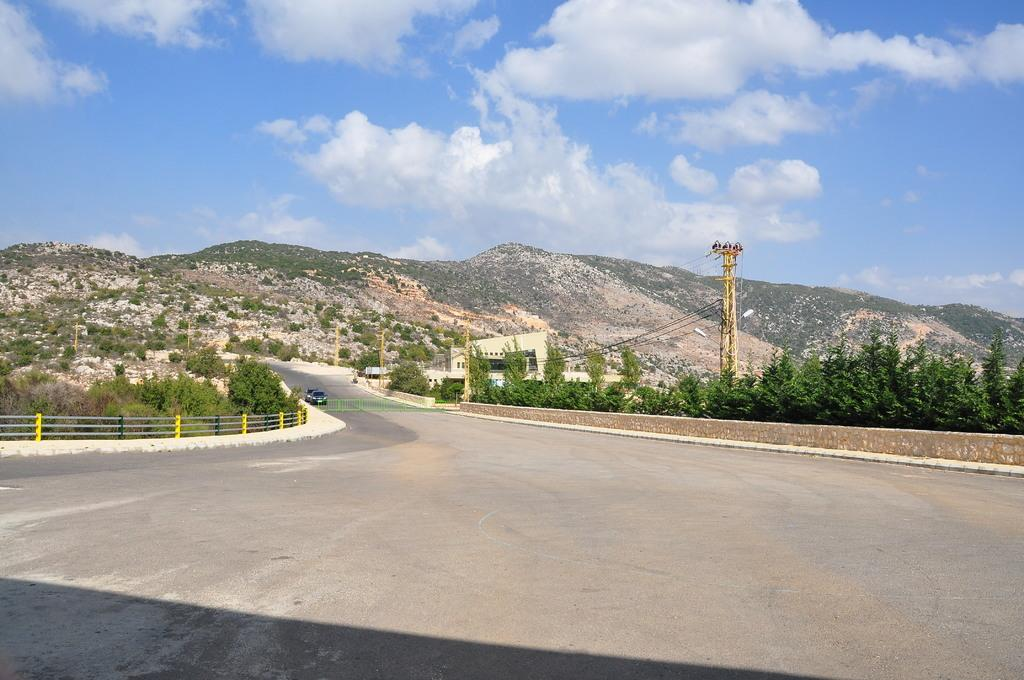What type of vehicles can be seen on the road in the image? There are motor vehicles on the road in the image. What structures are present to provide safety or boundaries in the image? Railings are present in the image. What type of natural elements can be seen in the image? Trees and hills are present in the image. What type of man-made structures can be seen in the image? Buildings are present in the image. What type of infrastructure is present in the image? Electric poles and electric cables are visible in the image. What is visible in the sky in the image? The sky is visible in the image, and clouds are present in the sky. What type of underwear is hanging on the electric poles in the image? There is no underwear present in the image; only electric poles, electric cables, and other elements mentioned in the facts are visible. How does the image show the fact that the Earth is round? The image does not show any evidence or indication of the Earth's shape, as it only depicts a scene with motor vehicles, railings, trees, buildings, electric poles, electric cables, hills, and the sky. 